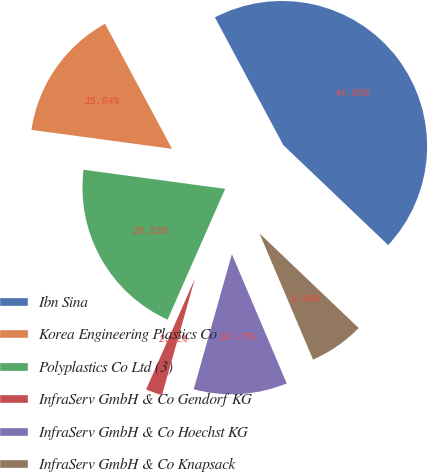Convert chart to OTSL. <chart><loc_0><loc_0><loc_500><loc_500><pie_chart><fcel>Ibn Sina<fcel>Korea Engineering Plastics Co<fcel>Polyplastics Co Ltd (3)<fcel>InfraServ GmbH & Co Gendorf KG<fcel>InfraServ GmbH & Co Hoechst KG<fcel>InfraServ GmbH & Co Knapsack<nl><fcel>44.95%<fcel>15.04%<fcel>20.53%<fcel>2.22%<fcel>10.77%<fcel>6.49%<nl></chart> 